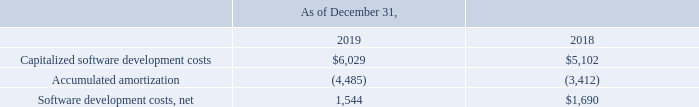Note 9 - Software Development Costs
Capitalized software development costs as of December 31, 2019 and 2018 consisted of the following (in thousands):
The weighted average remaining amortization period for the Company’s software development costs is 1.61 years.
Amortization expense for capitalized software development costs was $1.025 million and $1.2 million for each of the years ended December 31, 2019 and 2018.
What was the weighted average remaining amortization period for the Company’s software development costs? 1.61 years. What was the net software development costs in 2019?
Answer scale should be: thousand. 1,544. What was the Capitalized software development costs in 2019?
Answer scale should be: thousand. $6,029. In which year was Capitalized software development costs less than 6,000 thousands? Locate and analyze capitalized software development costs in row 3
answer: 2018. What was the average Software development costs, net for 2018 and 2019?
Answer scale should be: thousand. (1,544 + 1,690) / 2
Answer: 1617. What was the change in Accumulated amortization from 2018 to 2019?
Answer scale should be: thousand. -4,485 - (-3,412)
Answer: -1073. 